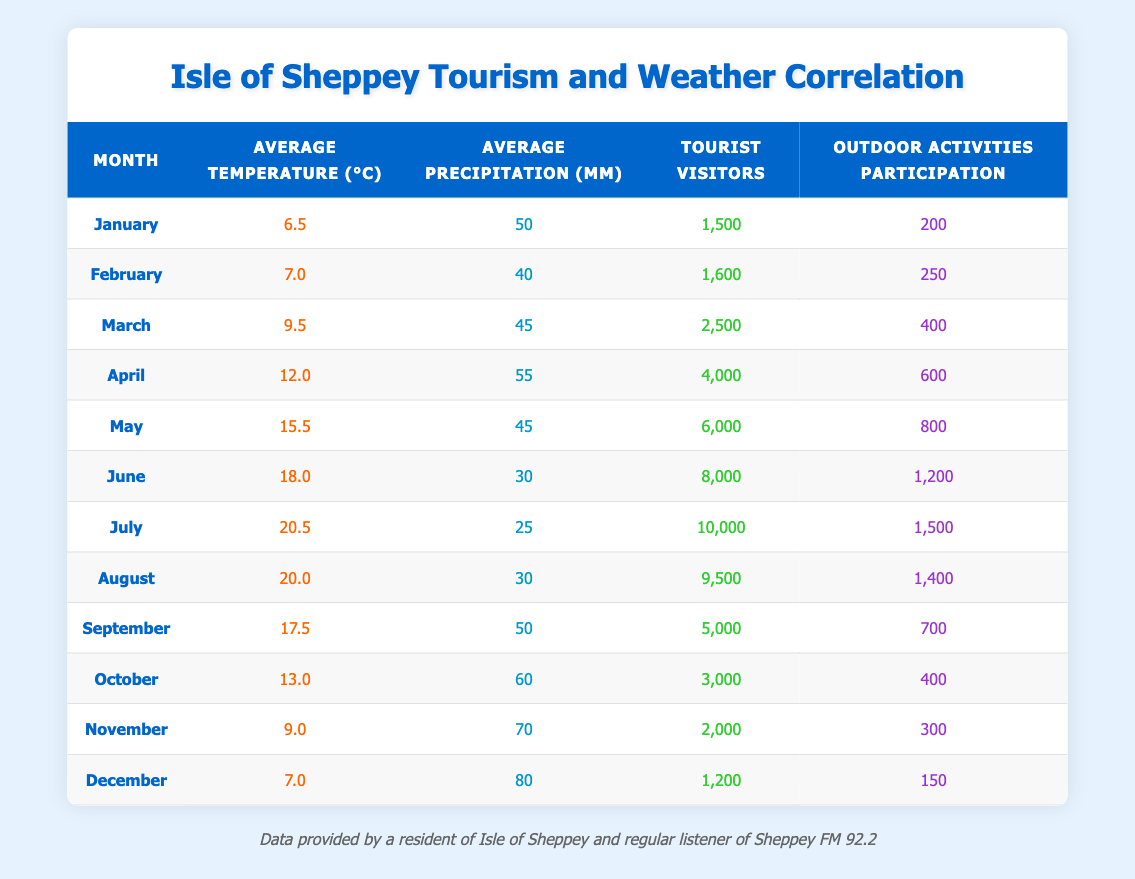What was the average number of tourist visitors in July and August combined? The number of tourist visitors in July is 10,000 and in August is 9,500. Combining these gives 10,000 + 9,500 = 19,500. To find the average of these two months, we divide this total by 2. Thus, the average is 19,500 / 2 = 9,750.
Answer: 9,750 In which month did the highest outdoor activities participation occur? By looking at the outdoor activities participation column, July shows the highest participation with 1,500 activities compared to other months.
Answer: July Was the average precipitation in October greater than in November? The average precipitation for October is 60 mm and for November is 70 mm. Since 60 mm is less than 70 mm, the statement is false.
Answer: No What is the difference in tourist visitors between the month with the highest and the lowest number of visitors? The highest number of tourist visitors occurs in July with 10,000 visitors, and the lowest is in January with 1,500. The difference is calculated as 10,000 - 1,500 = 8,500.
Answer: 8,500 How many months had an average temperature above 15 degrees Celsius? The months with an average temperature above 15 degrees Celsius are May (15.5), June (18.0), and July (20.5). This totals 3 months.
Answer: 3 What is the total average precipitation for the summer months (June, July, August)? The average precipitation for June is 30 mm, July is 25 mm, and August is 30 mm. Adding these gives 30 + 25 + 30 = 85 mm. To find the average, divide by 3, resulting in 85 / 3 ≈ 28.33 mm.
Answer: 28.33 mm Is it true that December had more tourist visitors than November? The number of tourist visitors in December is 1,200 and in November it is 2,000. Since 1,200 is less than 2,000, the statement is false.
Answer: No What percentage of outdoor activities participation occurred in April compared to July? In April, outdoor activities participation was 600 and in July it was 1,500. To find the percentage, divide 600 by 1,500 and multiply by 100. This gives (600 / 1,500) * 100 = 40%.
Answer: 40% Which month had a decline in both tourist visitors and outdoor activities participation compared to the previous month? Observing the data, we see that October has 3,000 visitors (down from September's 5,000) and outdoor participation of 400 (down from September's 700). Therefore, October had a decline in both metrics compared to September.
Answer: October 